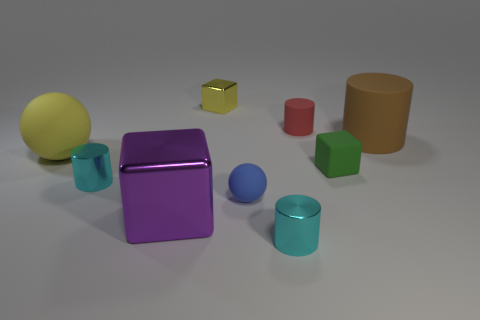Are there any other things that have the same color as the large shiny object?
Offer a terse response. No. What number of blue objects are either shiny blocks or small matte blocks?
Offer a very short reply. 0. Does the metal object that is behind the big yellow rubber ball have the same shape as the tiny green rubber object behind the big purple shiny block?
Offer a very short reply. Yes. There is a small shiny cube; is its color the same as the big rubber thing left of the red cylinder?
Provide a short and direct response. Yes. Does the tiny cube to the left of the red matte cylinder have the same color as the large rubber ball?
Keep it short and to the point. Yes. What number of things are either cylinders or shiny things in front of the blue thing?
Offer a very short reply. 5. The cube that is in front of the small red rubber cylinder and left of the small red cylinder is made of what material?
Your answer should be very brief. Metal. There is a large yellow object to the left of the big cube; what material is it?
Offer a terse response. Rubber. What is the color of the big ball that is made of the same material as the big brown cylinder?
Keep it short and to the point. Yellow. There is a brown thing; is it the same shape as the large matte object that is on the left side of the tiny green cube?
Your response must be concise. No. 